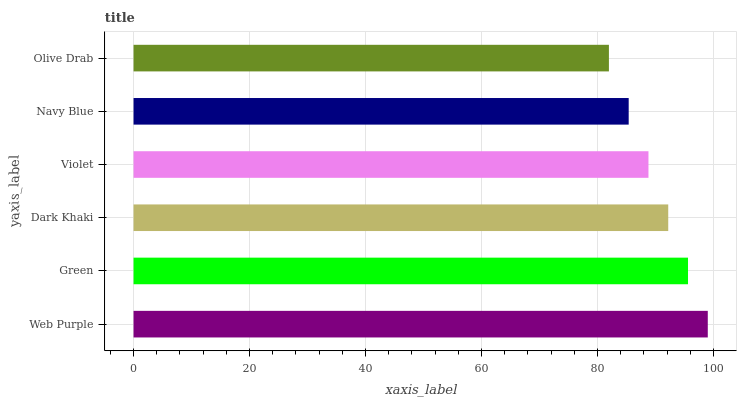Is Olive Drab the minimum?
Answer yes or no. Yes. Is Web Purple the maximum?
Answer yes or no. Yes. Is Green the minimum?
Answer yes or no. No. Is Green the maximum?
Answer yes or no. No. Is Web Purple greater than Green?
Answer yes or no. Yes. Is Green less than Web Purple?
Answer yes or no. Yes. Is Green greater than Web Purple?
Answer yes or no. No. Is Web Purple less than Green?
Answer yes or no. No. Is Dark Khaki the high median?
Answer yes or no. Yes. Is Violet the low median?
Answer yes or no. Yes. Is Green the high median?
Answer yes or no. No. Is Web Purple the low median?
Answer yes or no. No. 